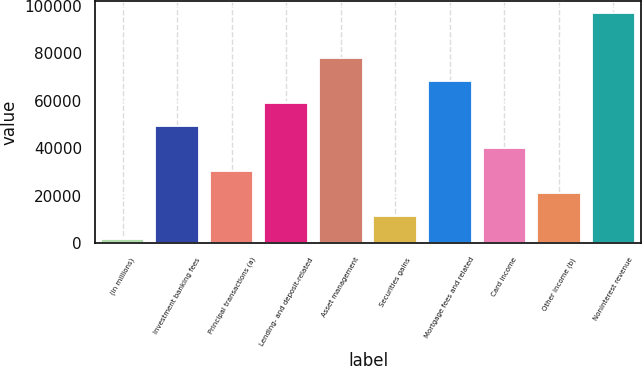Convert chart to OTSL. <chart><loc_0><loc_0><loc_500><loc_500><bar_chart><fcel>(in millions)<fcel>Investment banking fees<fcel>Principal transactions (a)<fcel>Lending- and deposit-related<fcel>Asset management<fcel>Securities gains<fcel>Mortgage fees and related<fcel>Card income<fcel>Other income (b)<fcel>Noninterest revenue<nl><fcel>2012<fcel>49521.5<fcel>30517.7<fcel>59023.4<fcel>78027.2<fcel>11513.9<fcel>68525.3<fcel>40019.6<fcel>21015.8<fcel>97031<nl></chart> 